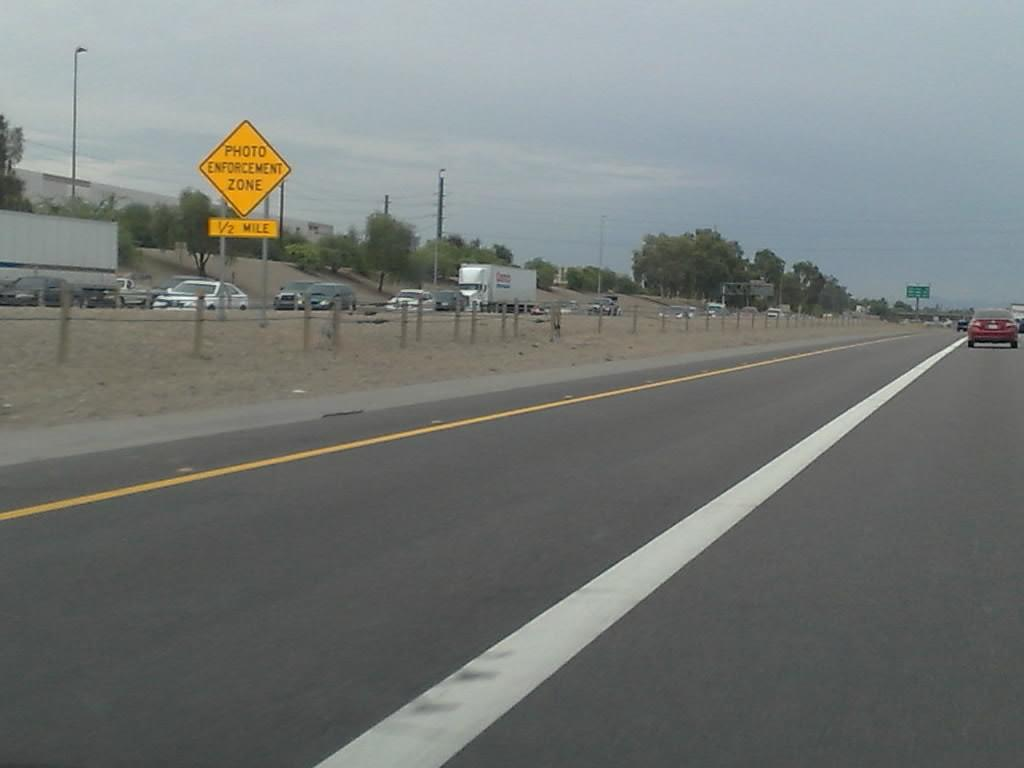<image>
Describe the image concisely. A yellow sign saying Photo Enforcement Zone stands int the middle of the reservation of a busy road. 